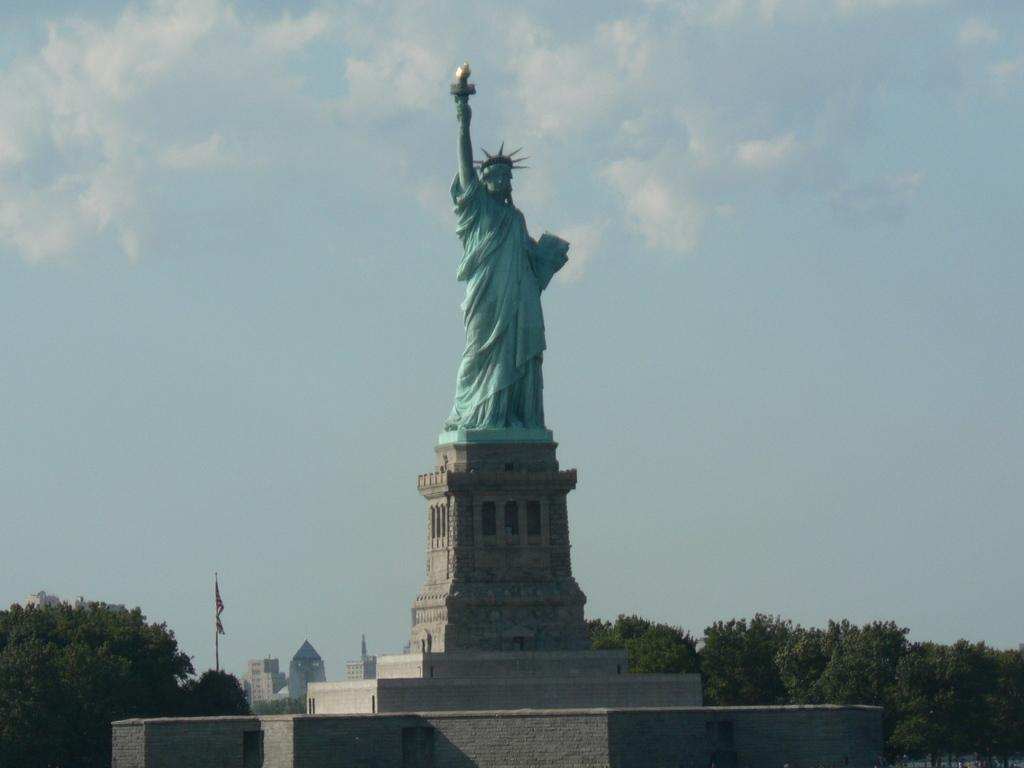What is the main subject of the image? There is a statue in the image. How is the statue positioned in the image? The statue is placed on the ground. What can be seen in the background of the image? There is a group of trees, buildings, a flag, and the sky visible in the background of the image. What type of rabbit can be seen hopping on the moon in the image? There is no rabbit or moon present in the image; it features a statue placed on the ground with a background that includes trees, buildings, a flag, and the sky. 